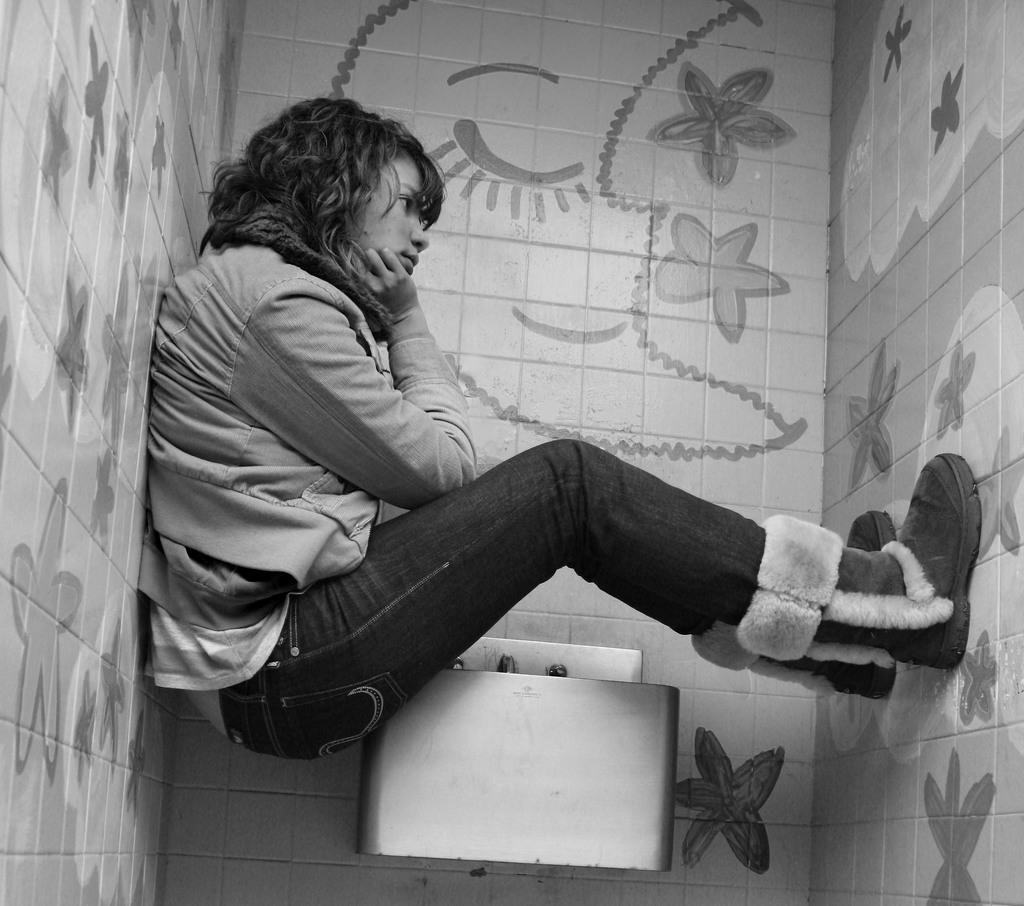In one or two sentences, can you explain what this image depicts? This is a black and white image, in this image there is a lady sitting on a sink, around her there are walls. 